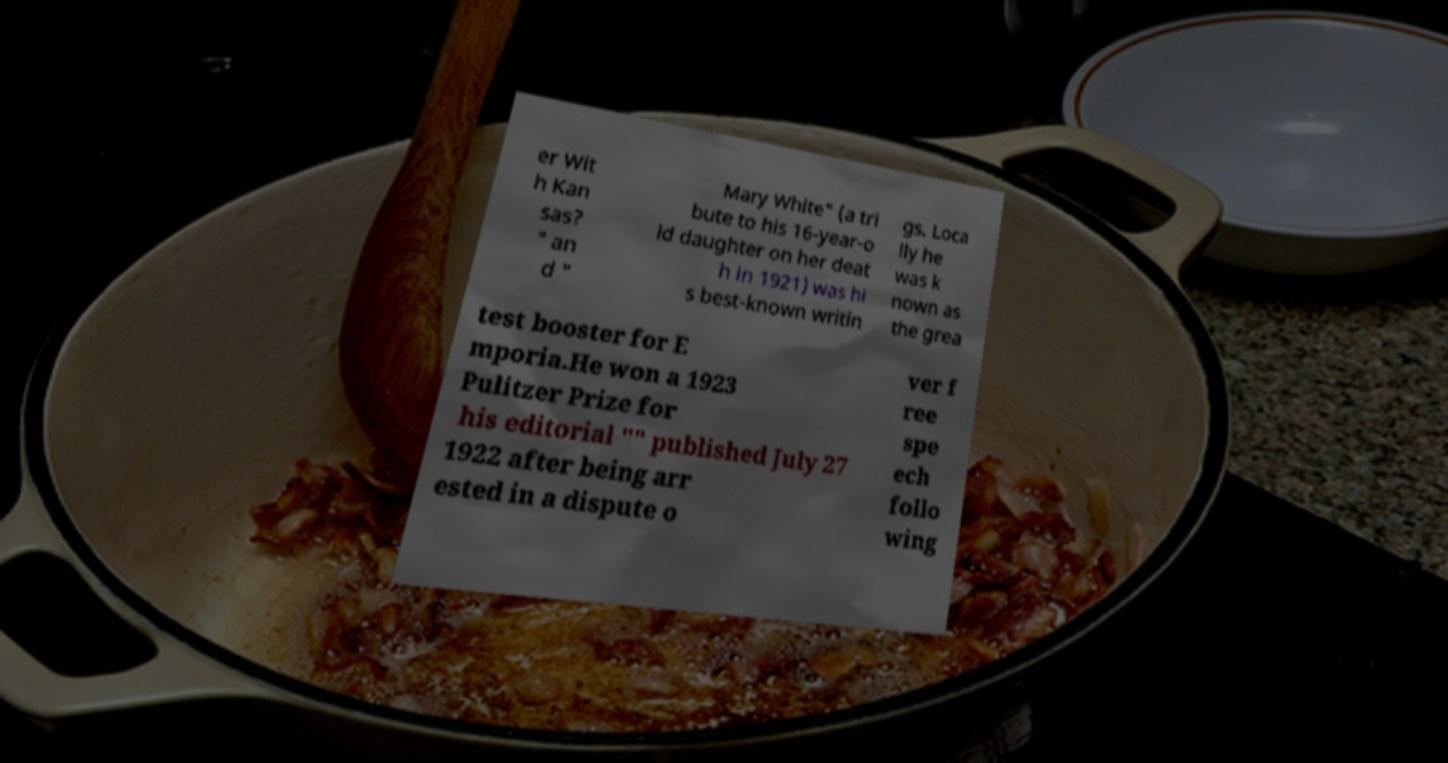What messages or text are displayed in this image? I need them in a readable, typed format. er Wit h Kan sas? " an d " Mary White" (a tri bute to his 16-year-o ld daughter on her deat h in 1921) was hi s best-known writin gs. Loca lly he was k nown as the grea test booster for E mporia.He won a 1923 Pulitzer Prize for his editorial "" published July 27 1922 after being arr ested in a dispute o ver f ree spe ech follo wing 